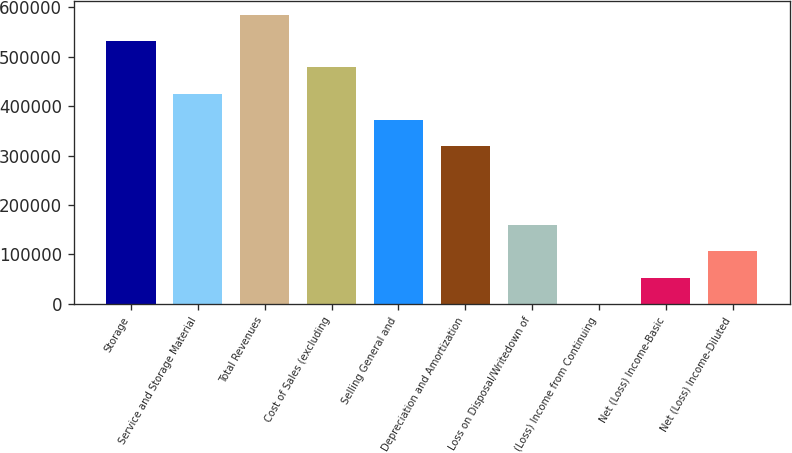Convert chart. <chart><loc_0><loc_0><loc_500><loc_500><bar_chart><fcel>Storage<fcel>Service and Storage Material<fcel>Total Revenues<fcel>Cost of Sales (excluding<fcel>Selling General and<fcel>Depreciation and Amortization<fcel>Loss on Disposal/Writedown of<fcel>(Loss) Income from Continuing<fcel>Net (Loss) Income-Basic<fcel>Net (Loss) Income-Diluted<nl><fcel>531389<fcel>425111<fcel>584528<fcel>478250<fcel>371972<fcel>318833<fcel>159417<fcel>0.02<fcel>53138.9<fcel>106278<nl></chart> 